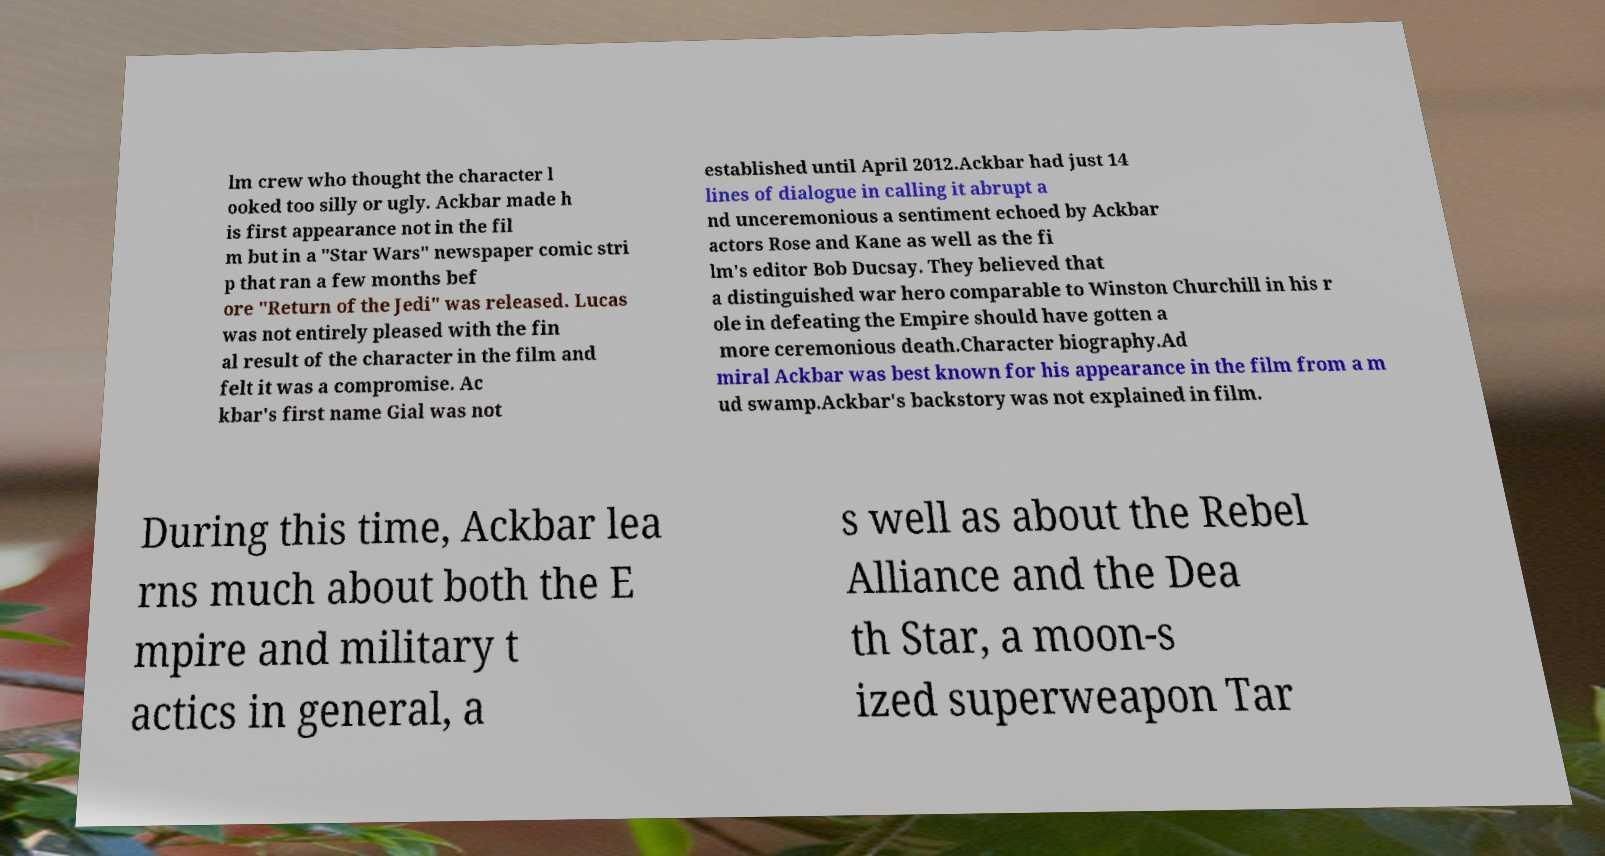Can you accurately transcribe the text from the provided image for me? lm crew who thought the character l ooked too silly or ugly. Ackbar made h is first appearance not in the fil m but in a "Star Wars" newspaper comic stri p that ran a few months bef ore "Return of the Jedi" was released. Lucas was not entirely pleased with the fin al result of the character in the film and felt it was a compromise. Ac kbar's first name Gial was not established until April 2012.Ackbar had just 14 lines of dialogue in calling it abrupt a nd unceremonious a sentiment echoed by Ackbar actors Rose and Kane as well as the fi lm's editor Bob Ducsay. They believed that a distinguished war hero comparable to Winston Churchill in his r ole in defeating the Empire should have gotten a more ceremonious death.Character biography.Ad miral Ackbar was best known for his appearance in the film from a m ud swamp.Ackbar's backstory was not explained in film. During this time, Ackbar lea rns much about both the E mpire and military t actics in general, a s well as about the Rebel Alliance and the Dea th Star, a moon-s ized superweapon Tar 